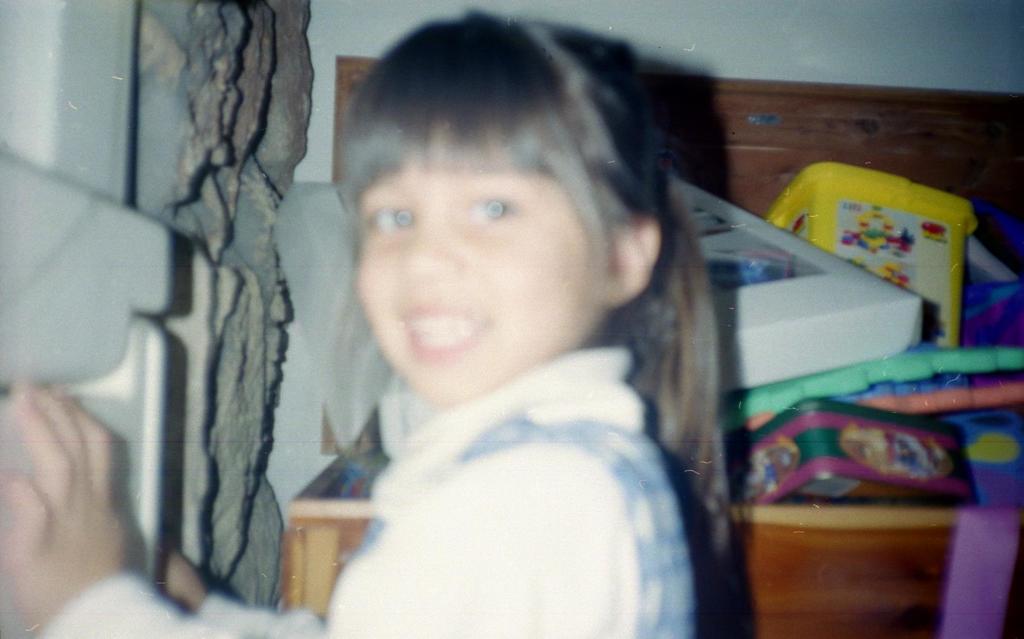In one or two sentences, can you explain what this image depicts? In this image in the front there is a girl smiling. In the background there are objects which are white, yellow and green in colour, which is on the the wooden block. On the left side there is stone type object which is visible. 